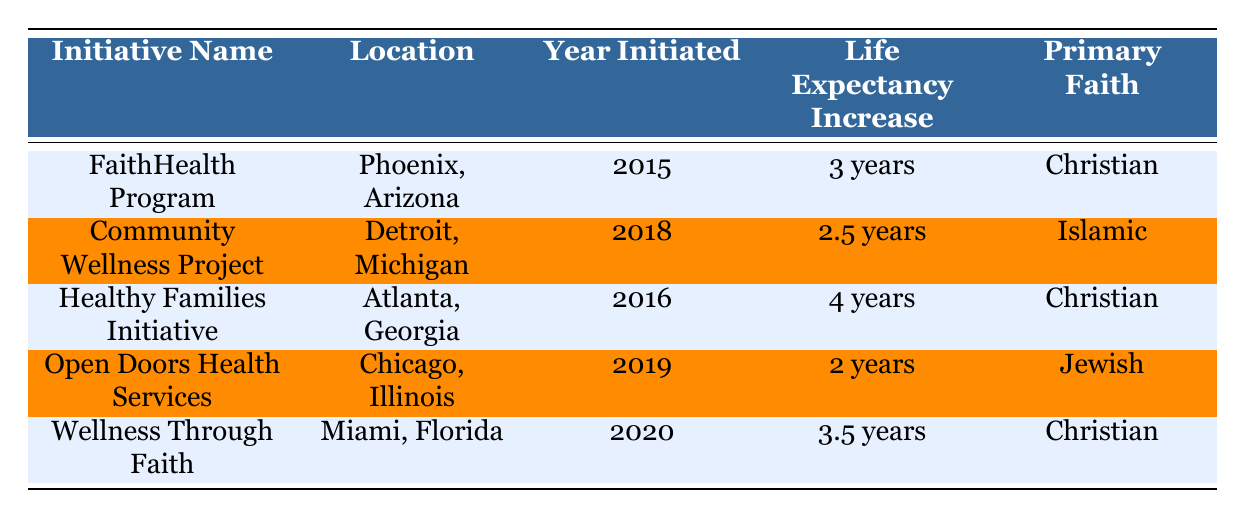What is the life expectancy increase associated with the Healthy Families Initiative? The table shows that the Healthy Families Initiative has a life expectancy increase of "4 years." We can directly find this in the "Life Expectancy Increase" column for the corresponding initiative.
Answer: 4 years Which initiative has the highest life expectancy increase? By comparing the values in the "Life Expectancy Increase" column, the Healthy Families Initiative has the highest increase at "4 years." This is confirmed by checking each value listed in the table.
Answer: Healthy Families Initiative Is the primary faith for the Open Doors Health Services initiative Jewish? Yes, according to the table, the "Primary Faith" for the Open Doors Health Services initiative is listed as "Jewish." This information can be found directly under the corresponding row in the table.
Answer: Yes How many years of life expectancy increase can be attributed to the FaithHealth Program and the Wellness Through Faith initiatives combined? The FaithHealth Program shows a life expectancy increase of "3 years," and the Wellness Through Faith initiative shows an increase of "3.5 years." By summing these values (3 + 3.5 = 6.5), we find the combined increase.
Answer: 6.5 years What percentage improvement in health outcomes is associated with the Community Wellness Project? The Community Wellness Project indicates a "15% increase in mental health service utilization." This specific information can be found directly in the row for the Community Wellness Project under the health outcome improvement column.
Answer: 15% 